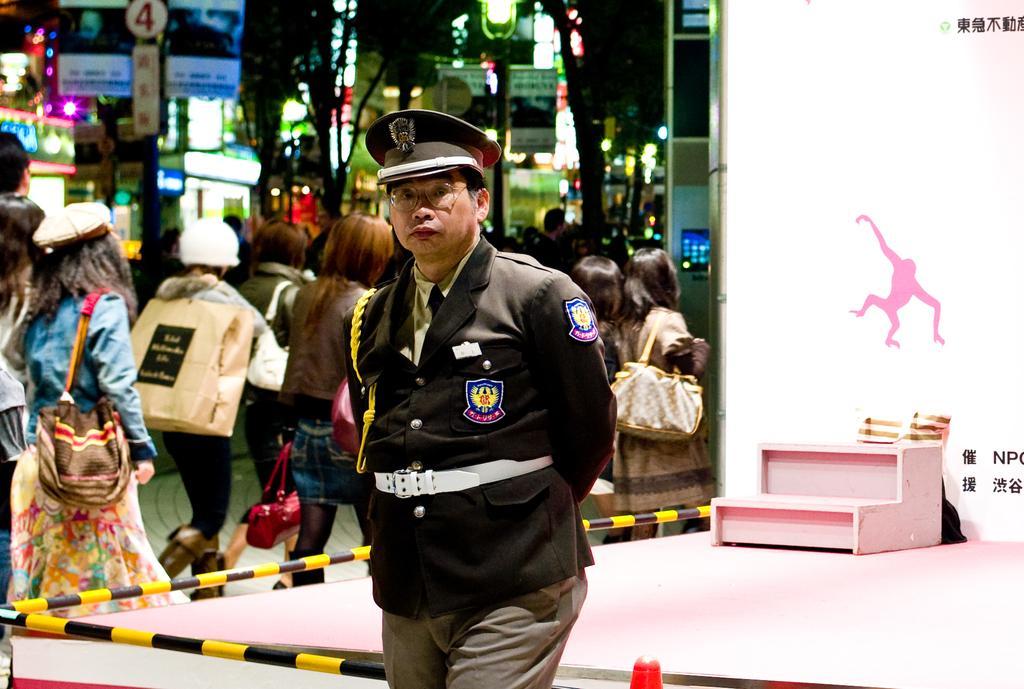In one or two sentences, can you explain what this image depicts? In this image there is a man standing, he is wearing a cap, there are a group of persons walking, they are holding an object, they are wearing a bag, there is a pole, there are boards, there is text and numbers on the boards, there is a light towards the top of the image, there are buildings, there is a stage towards the bottom of the image, there is an object on the stage, there is a board towards the right of the image, there is text on the board. 